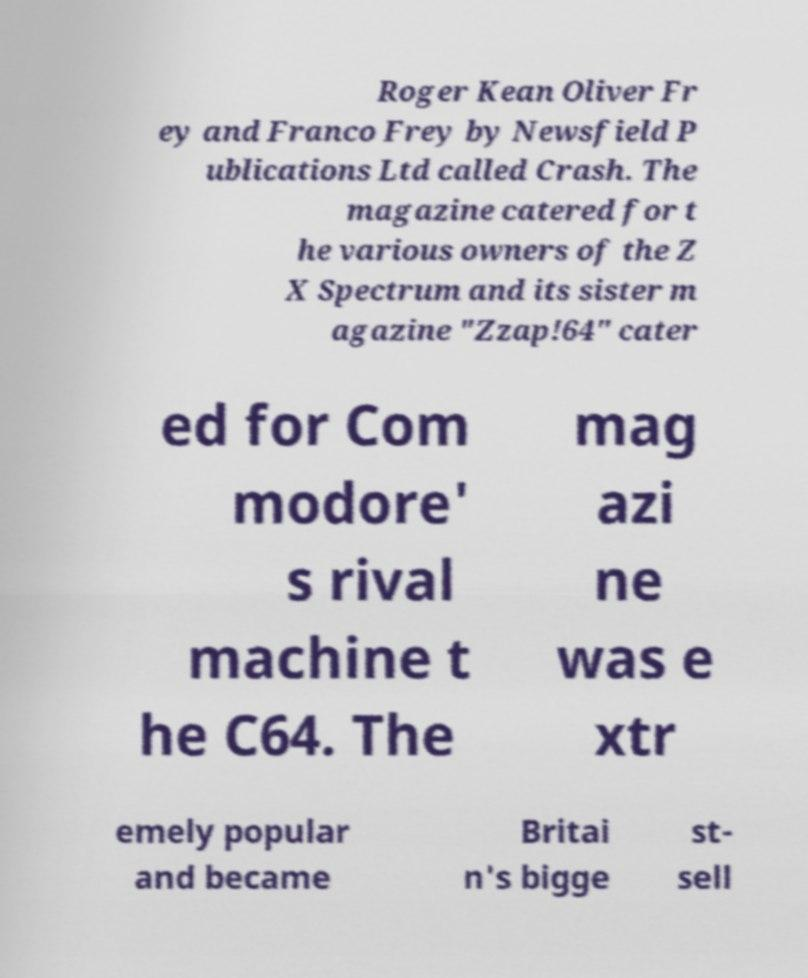What messages or text are displayed in this image? I need them in a readable, typed format. Roger Kean Oliver Fr ey and Franco Frey by Newsfield P ublications Ltd called Crash. The magazine catered for t he various owners of the Z X Spectrum and its sister m agazine "Zzap!64" cater ed for Com modore' s rival machine t he C64. The mag azi ne was e xtr emely popular and became Britai n's bigge st- sell 